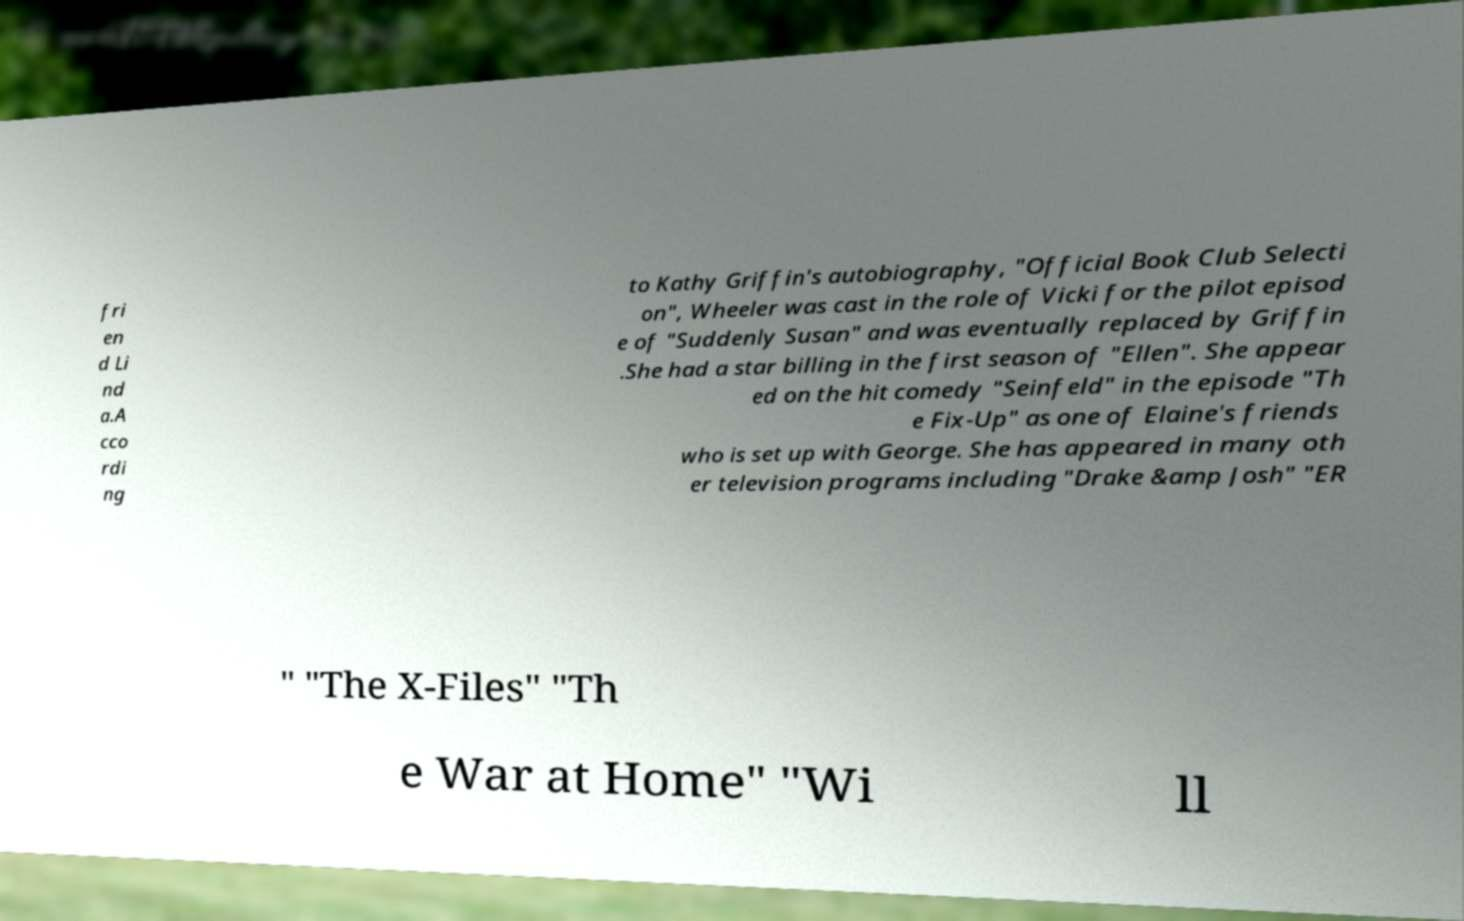I need the written content from this picture converted into text. Can you do that? fri en d Li nd a.A cco rdi ng to Kathy Griffin's autobiography, "Official Book Club Selecti on", Wheeler was cast in the role of Vicki for the pilot episod e of "Suddenly Susan" and was eventually replaced by Griffin .She had a star billing in the first season of "Ellen". She appear ed on the hit comedy "Seinfeld" in the episode "Th e Fix-Up" as one of Elaine's friends who is set up with George. She has appeared in many oth er television programs including "Drake &amp Josh" "ER " "The X-Files" "Th e War at Home" "Wi ll 